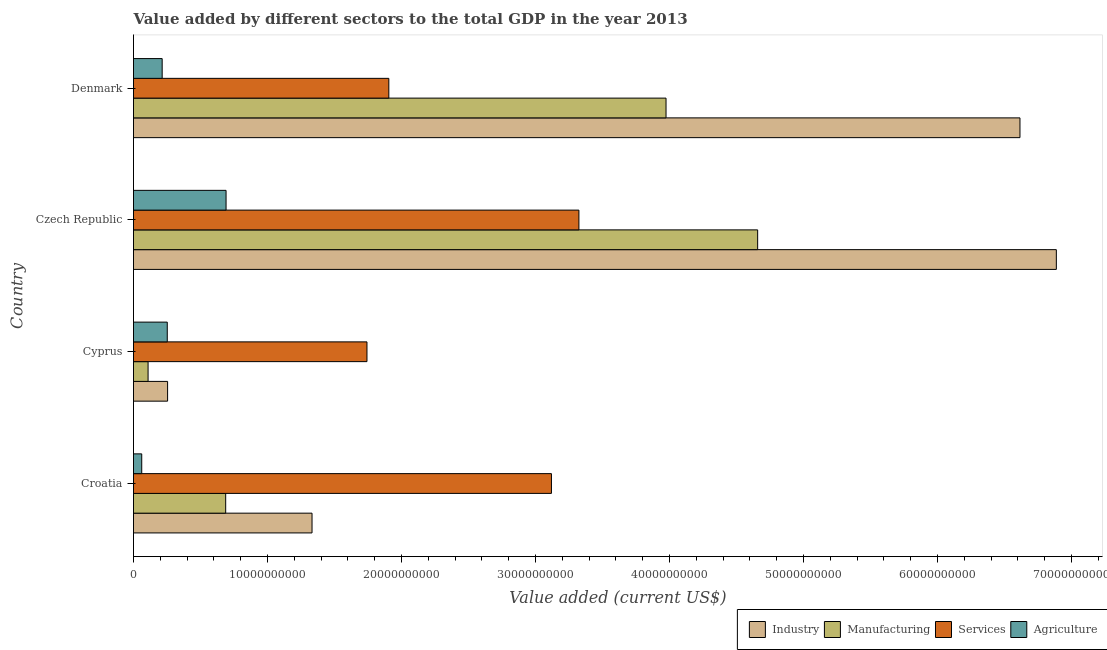Are the number of bars per tick equal to the number of legend labels?
Offer a very short reply. Yes. Are the number of bars on each tick of the Y-axis equal?
Your answer should be compact. Yes. How many bars are there on the 3rd tick from the bottom?
Provide a succinct answer. 4. What is the label of the 1st group of bars from the top?
Keep it short and to the point. Denmark. What is the value added by manufacturing sector in Cyprus?
Your response must be concise. 1.09e+09. Across all countries, what is the maximum value added by manufacturing sector?
Your answer should be compact. 4.66e+1. Across all countries, what is the minimum value added by manufacturing sector?
Keep it short and to the point. 1.09e+09. In which country was the value added by manufacturing sector maximum?
Your answer should be compact. Czech Republic. In which country was the value added by services sector minimum?
Ensure brevity in your answer.  Cyprus. What is the total value added by industrial sector in the graph?
Offer a terse response. 1.51e+11. What is the difference between the value added by industrial sector in Croatia and that in Denmark?
Keep it short and to the point. -5.28e+1. What is the difference between the value added by agricultural sector in Croatia and the value added by manufacturing sector in Cyprus?
Provide a short and direct response. -4.73e+08. What is the average value added by services sector per country?
Make the answer very short. 2.52e+1. What is the difference between the value added by manufacturing sector and value added by agricultural sector in Czech Republic?
Provide a succinct answer. 3.97e+1. What is the ratio of the value added by manufacturing sector in Cyprus to that in Denmark?
Provide a succinct answer. 0.03. Is the value added by services sector in Croatia less than that in Czech Republic?
Make the answer very short. Yes. What is the difference between the highest and the second highest value added by manufacturing sector?
Provide a short and direct response. 6.84e+09. What is the difference between the highest and the lowest value added by manufacturing sector?
Your response must be concise. 4.55e+1. What does the 4th bar from the top in Cyprus represents?
Make the answer very short. Industry. What does the 4th bar from the bottom in Denmark represents?
Ensure brevity in your answer.  Agriculture. How many bars are there?
Offer a very short reply. 16. What is the difference between two consecutive major ticks on the X-axis?
Provide a short and direct response. 1.00e+1. Are the values on the major ticks of X-axis written in scientific E-notation?
Your answer should be very brief. No. Does the graph contain any zero values?
Your answer should be very brief. No. Where does the legend appear in the graph?
Your answer should be very brief. Bottom right. How many legend labels are there?
Your answer should be very brief. 4. What is the title of the graph?
Offer a terse response. Value added by different sectors to the total GDP in the year 2013. What is the label or title of the X-axis?
Your response must be concise. Value added (current US$). What is the Value added (current US$) in Industry in Croatia?
Provide a succinct answer. 1.33e+1. What is the Value added (current US$) of Manufacturing in Croatia?
Give a very brief answer. 6.88e+09. What is the Value added (current US$) in Services in Croatia?
Ensure brevity in your answer.  3.12e+1. What is the Value added (current US$) in Agriculture in Croatia?
Provide a short and direct response. 6.14e+08. What is the Value added (current US$) in Industry in Cyprus?
Provide a short and direct response. 2.54e+09. What is the Value added (current US$) in Manufacturing in Cyprus?
Give a very brief answer. 1.09e+09. What is the Value added (current US$) in Services in Cyprus?
Your answer should be very brief. 1.74e+1. What is the Value added (current US$) of Agriculture in Cyprus?
Keep it short and to the point. 2.52e+09. What is the Value added (current US$) of Industry in Czech Republic?
Your response must be concise. 6.89e+1. What is the Value added (current US$) of Manufacturing in Czech Republic?
Give a very brief answer. 4.66e+1. What is the Value added (current US$) in Services in Czech Republic?
Your response must be concise. 3.32e+1. What is the Value added (current US$) in Agriculture in Czech Republic?
Provide a succinct answer. 6.91e+09. What is the Value added (current US$) of Industry in Denmark?
Give a very brief answer. 6.61e+1. What is the Value added (current US$) in Manufacturing in Denmark?
Offer a very short reply. 3.97e+1. What is the Value added (current US$) of Services in Denmark?
Ensure brevity in your answer.  1.91e+1. What is the Value added (current US$) in Agriculture in Denmark?
Your response must be concise. 2.14e+09. Across all countries, what is the maximum Value added (current US$) in Industry?
Your response must be concise. 6.89e+1. Across all countries, what is the maximum Value added (current US$) of Manufacturing?
Your response must be concise. 4.66e+1. Across all countries, what is the maximum Value added (current US$) of Services?
Make the answer very short. 3.32e+1. Across all countries, what is the maximum Value added (current US$) of Agriculture?
Provide a succinct answer. 6.91e+09. Across all countries, what is the minimum Value added (current US$) in Industry?
Keep it short and to the point. 2.54e+09. Across all countries, what is the minimum Value added (current US$) of Manufacturing?
Your response must be concise. 1.09e+09. Across all countries, what is the minimum Value added (current US$) in Services?
Give a very brief answer. 1.74e+1. Across all countries, what is the minimum Value added (current US$) in Agriculture?
Offer a terse response. 6.14e+08. What is the total Value added (current US$) of Industry in the graph?
Your answer should be compact. 1.51e+11. What is the total Value added (current US$) of Manufacturing in the graph?
Ensure brevity in your answer.  9.43e+1. What is the total Value added (current US$) of Services in the graph?
Provide a succinct answer. 1.01e+11. What is the total Value added (current US$) of Agriculture in the graph?
Offer a very short reply. 1.22e+1. What is the difference between the Value added (current US$) of Industry in Croatia and that in Cyprus?
Ensure brevity in your answer.  1.08e+1. What is the difference between the Value added (current US$) of Manufacturing in Croatia and that in Cyprus?
Your response must be concise. 5.79e+09. What is the difference between the Value added (current US$) of Services in Croatia and that in Cyprus?
Give a very brief answer. 1.38e+1. What is the difference between the Value added (current US$) of Agriculture in Croatia and that in Cyprus?
Keep it short and to the point. -1.90e+09. What is the difference between the Value added (current US$) in Industry in Croatia and that in Czech Republic?
Keep it short and to the point. -5.55e+1. What is the difference between the Value added (current US$) in Manufacturing in Croatia and that in Czech Republic?
Keep it short and to the point. -3.97e+1. What is the difference between the Value added (current US$) in Services in Croatia and that in Czech Republic?
Ensure brevity in your answer.  -2.05e+09. What is the difference between the Value added (current US$) in Agriculture in Croatia and that in Czech Republic?
Make the answer very short. -6.29e+09. What is the difference between the Value added (current US$) of Industry in Croatia and that in Denmark?
Your answer should be compact. -5.28e+1. What is the difference between the Value added (current US$) of Manufacturing in Croatia and that in Denmark?
Provide a succinct answer. -3.29e+1. What is the difference between the Value added (current US$) of Services in Croatia and that in Denmark?
Offer a very short reply. 1.21e+1. What is the difference between the Value added (current US$) in Agriculture in Croatia and that in Denmark?
Your response must be concise. -1.52e+09. What is the difference between the Value added (current US$) of Industry in Cyprus and that in Czech Republic?
Your answer should be compact. -6.63e+1. What is the difference between the Value added (current US$) in Manufacturing in Cyprus and that in Czech Republic?
Your response must be concise. -4.55e+1. What is the difference between the Value added (current US$) in Services in Cyprus and that in Czech Republic?
Offer a terse response. -1.58e+1. What is the difference between the Value added (current US$) of Agriculture in Cyprus and that in Czech Republic?
Offer a terse response. -4.39e+09. What is the difference between the Value added (current US$) of Industry in Cyprus and that in Denmark?
Give a very brief answer. -6.36e+1. What is the difference between the Value added (current US$) in Manufacturing in Cyprus and that in Denmark?
Your answer should be compact. -3.87e+1. What is the difference between the Value added (current US$) in Services in Cyprus and that in Denmark?
Provide a succinct answer. -1.63e+09. What is the difference between the Value added (current US$) in Agriculture in Cyprus and that in Denmark?
Your answer should be compact. 3.80e+08. What is the difference between the Value added (current US$) of Industry in Czech Republic and that in Denmark?
Your answer should be compact. 2.72e+09. What is the difference between the Value added (current US$) in Manufacturing in Czech Republic and that in Denmark?
Your response must be concise. 6.84e+09. What is the difference between the Value added (current US$) in Services in Czech Republic and that in Denmark?
Make the answer very short. 1.42e+1. What is the difference between the Value added (current US$) in Agriculture in Czech Republic and that in Denmark?
Keep it short and to the point. 4.77e+09. What is the difference between the Value added (current US$) in Industry in Croatia and the Value added (current US$) in Manufacturing in Cyprus?
Ensure brevity in your answer.  1.22e+1. What is the difference between the Value added (current US$) of Industry in Croatia and the Value added (current US$) of Services in Cyprus?
Your answer should be very brief. -4.10e+09. What is the difference between the Value added (current US$) of Industry in Croatia and the Value added (current US$) of Agriculture in Cyprus?
Your response must be concise. 1.08e+1. What is the difference between the Value added (current US$) in Manufacturing in Croatia and the Value added (current US$) in Services in Cyprus?
Provide a succinct answer. -1.05e+1. What is the difference between the Value added (current US$) in Manufacturing in Croatia and the Value added (current US$) in Agriculture in Cyprus?
Make the answer very short. 4.36e+09. What is the difference between the Value added (current US$) of Services in Croatia and the Value added (current US$) of Agriculture in Cyprus?
Your answer should be very brief. 2.87e+1. What is the difference between the Value added (current US$) in Industry in Croatia and the Value added (current US$) in Manufacturing in Czech Republic?
Your answer should be very brief. -3.33e+1. What is the difference between the Value added (current US$) of Industry in Croatia and the Value added (current US$) of Services in Czech Republic?
Offer a very short reply. -1.99e+1. What is the difference between the Value added (current US$) of Industry in Croatia and the Value added (current US$) of Agriculture in Czech Republic?
Keep it short and to the point. 6.42e+09. What is the difference between the Value added (current US$) in Manufacturing in Croatia and the Value added (current US$) in Services in Czech Republic?
Your response must be concise. -2.64e+1. What is the difference between the Value added (current US$) in Manufacturing in Croatia and the Value added (current US$) in Agriculture in Czech Republic?
Ensure brevity in your answer.  -2.79e+07. What is the difference between the Value added (current US$) in Services in Croatia and the Value added (current US$) in Agriculture in Czech Republic?
Your answer should be very brief. 2.43e+1. What is the difference between the Value added (current US$) in Industry in Croatia and the Value added (current US$) in Manufacturing in Denmark?
Offer a very short reply. -2.64e+1. What is the difference between the Value added (current US$) of Industry in Croatia and the Value added (current US$) of Services in Denmark?
Your answer should be compact. -5.73e+09. What is the difference between the Value added (current US$) in Industry in Croatia and the Value added (current US$) in Agriculture in Denmark?
Offer a terse response. 1.12e+1. What is the difference between the Value added (current US$) in Manufacturing in Croatia and the Value added (current US$) in Services in Denmark?
Give a very brief answer. -1.22e+1. What is the difference between the Value added (current US$) in Manufacturing in Croatia and the Value added (current US$) in Agriculture in Denmark?
Ensure brevity in your answer.  4.74e+09. What is the difference between the Value added (current US$) in Services in Croatia and the Value added (current US$) in Agriculture in Denmark?
Ensure brevity in your answer.  2.90e+1. What is the difference between the Value added (current US$) in Industry in Cyprus and the Value added (current US$) in Manufacturing in Czech Republic?
Keep it short and to the point. -4.40e+1. What is the difference between the Value added (current US$) in Industry in Cyprus and the Value added (current US$) in Services in Czech Republic?
Your answer should be very brief. -3.07e+1. What is the difference between the Value added (current US$) of Industry in Cyprus and the Value added (current US$) of Agriculture in Czech Republic?
Offer a terse response. -4.36e+09. What is the difference between the Value added (current US$) of Manufacturing in Cyprus and the Value added (current US$) of Services in Czech Republic?
Offer a terse response. -3.21e+1. What is the difference between the Value added (current US$) of Manufacturing in Cyprus and the Value added (current US$) of Agriculture in Czech Republic?
Keep it short and to the point. -5.82e+09. What is the difference between the Value added (current US$) of Services in Cyprus and the Value added (current US$) of Agriculture in Czech Republic?
Offer a very short reply. 1.05e+1. What is the difference between the Value added (current US$) in Industry in Cyprus and the Value added (current US$) in Manufacturing in Denmark?
Provide a short and direct response. -3.72e+1. What is the difference between the Value added (current US$) of Industry in Cyprus and the Value added (current US$) of Services in Denmark?
Keep it short and to the point. -1.65e+1. What is the difference between the Value added (current US$) of Industry in Cyprus and the Value added (current US$) of Agriculture in Denmark?
Make the answer very short. 4.04e+08. What is the difference between the Value added (current US$) of Manufacturing in Cyprus and the Value added (current US$) of Services in Denmark?
Make the answer very short. -1.80e+1. What is the difference between the Value added (current US$) of Manufacturing in Cyprus and the Value added (current US$) of Agriculture in Denmark?
Offer a terse response. -1.05e+09. What is the difference between the Value added (current US$) of Services in Cyprus and the Value added (current US$) of Agriculture in Denmark?
Make the answer very short. 1.53e+1. What is the difference between the Value added (current US$) in Industry in Czech Republic and the Value added (current US$) in Manufacturing in Denmark?
Offer a very short reply. 2.91e+1. What is the difference between the Value added (current US$) of Industry in Czech Republic and the Value added (current US$) of Services in Denmark?
Your answer should be very brief. 4.98e+1. What is the difference between the Value added (current US$) of Industry in Czech Republic and the Value added (current US$) of Agriculture in Denmark?
Offer a very short reply. 6.67e+1. What is the difference between the Value added (current US$) in Manufacturing in Czech Republic and the Value added (current US$) in Services in Denmark?
Give a very brief answer. 2.75e+1. What is the difference between the Value added (current US$) of Manufacturing in Czech Republic and the Value added (current US$) of Agriculture in Denmark?
Your response must be concise. 4.44e+1. What is the difference between the Value added (current US$) of Services in Czech Republic and the Value added (current US$) of Agriculture in Denmark?
Your answer should be compact. 3.11e+1. What is the average Value added (current US$) of Industry per country?
Ensure brevity in your answer.  3.77e+1. What is the average Value added (current US$) of Manufacturing per country?
Your answer should be very brief. 2.36e+1. What is the average Value added (current US$) in Services per country?
Give a very brief answer. 2.52e+1. What is the average Value added (current US$) in Agriculture per country?
Provide a succinct answer. 3.04e+09. What is the difference between the Value added (current US$) of Industry and Value added (current US$) of Manufacturing in Croatia?
Offer a terse response. 6.44e+09. What is the difference between the Value added (current US$) of Industry and Value added (current US$) of Services in Croatia?
Your response must be concise. -1.79e+1. What is the difference between the Value added (current US$) of Industry and Value added (current US$) of Agriculture in Croatia?
Provide a succinct answer. 1.27e+1. What is the difference between the Value added (current US$) in Manufacturing and Value added (current US$) in Services in Croatia?
Your answer should be very brief. -2.43e+1. What is the difference between the Value added (current US$) in Manufacturing and Value added (current US$) in Agriculture in Croatia?
Ensure brevity in your answer.  6.26e+09. What is the difference between the Value added (current US$) in Services and Value added (current US$) in Agriculture in Croatia?
Give a very brief answer. 3.06e+1. What is the difference between the Value added (current US$) of Industry and Value added (current US$) of Manufacturing in Cyprus?
Offer a very short reply. 1.46e+09. What is the difference between the Value added (current US$) of Industry and Value added (current US$) of Services in Cyprus?
Give a very brief answer. -1.49e+1. What is the difference between the Value added (current US$) in Industry and Value added (current US$) in Agriculture in Cyprus?
Make the answer very short. 2.38e+07. What is the difference between the Value added (current US$) in Manufacturing and Value added (current US$) in Services in Cyprus?
Provide a succinct answer. -1.63e+1. What is the difference between the Value added (current US$) in Manufacturing and Value added (current US$) in Agriculture in Cyprus?
Provide a succinct answer. -1.43e+09. What is the difference between the Value added (current US$) of Services and Value added (current US$) of Agriculture in Cyprus?
Keep it short and to the point. 1.49e+1. What is the difference between the Value added (current US$) in Industry and Value added (current US$) in Manufacturing in Czech Republic?
Provide a short and direct response. 2.23e+1. What is the difference between the Value added (current US$) of Industry and Value added (current US$) of Services in Czech Republic?
Provide a succinct answer. 3.56e+1. What is the difference between the Value added (current US$) of Industry and Value added (current US$) of Agriculture in Czech Republic?
Offer a very short reply. 6.20e+1. What is the difference between the Value added (current US$) in Manufacturing and Value added (current US$) in Services in Czech Republic?
Keep it short and to the point. 1.33e+1. What is the difference between the Value added (current US$) in Manufacturing and Value added (current US$) in Agriculture in Czech Republic?
Your response must be concise. 3.97e+1. What is the difference between the Value added (current US$) in Services and Value added (current US$) in Agriculture in Czech Republic?
Your answer should be compact. 2.63e+1. What is the difference between the Value added (current US$) of Industry and Value added (current US$) of Manufacturing in Denmark?
Make the answer very short. 2.64e+1. What is the difference between the Value added (current US$) in Industry and Value added (current US$) in Services in Denmark?
Give a very brief answer. 4.71e+1. What is the difference between the Value added (current US$) of Industry and Value added (current US$) of Agriculture in Denmark?
Offer a very short reply. 6.40e+1. What is the difference between the Value added (current US$) of Manufacturing and Value added (current US$) of Services in Denmark?
Your answer should be compact. 2.07e+1. What is the difference between the Value added (current US$) of Manufacturing and Value added (current US$) of Agriculture in Denmark?
Your answer should be very brief. 3.76e+1. What is the difference between the Value added (current US$) in Services and Value added (current US$) in Agriculture in Denmark?
Make the answer very short. 1.69e+1. What is the ratio of the Value added (current US$) of Industry in Croatia to that in Cyprus?
Provide a short and direct response. 5.24. What is the ratio of the Value added (current US$) in Manufacturing in Croatia to that in Cyprus?
Offer a terse response. 6.33. What is the ratio of the Value added (current US$) of Services in Croatia to that in Cyprus?
Give a very brief answer. 1.79. What is the ratio of the Value added (current US$) of Agriculture in Croatia to that in Cyprus?
Offer a terse response. 0.24. What is the ratio of the Value added (current US$) in Industry in Croatia to that in Czech Republic?
Your answer should be compact. 0.19. What is the ratio of the Value added (current US$) in Manufacturing in Croatia to that in Czech Republic?
Keep it short and to the point. 0.15. What is the ratio of the Value added (current US$) in Services in Croatia to that in Czech Republic?
Offer a very short reply. 0.94. What is the ratio of the Value added (current US$) in Agriculture in Croatia to that in Czech Republic?
Ensure brevity in your answer.  0.09. What is the ratio of the Value added (current US$) in Industry in Croatia to that in Denmark?
Offer a terse response. 0.2. What is the ratio of the Value added (current US$) in Manufacturing in Croatia to that in Denmark?
Offer a terse response. 0.17. What is the ratio of the Value added (current US$) in Services in Croatia to that in Denmark?
Ensure brevity in your answer.  1.64. What is the ratio of the Value added (current US$) of Agriculture in Croatia to that in Denmark?
Give a very brief answer. 0.29. What is the ratio of the Value added (current US$) of Industry in Cyprus to that in Czech Republic?
Give a very brief answer. 0.04. What is the ratio of the Value added (current US$) in Manufacturing in Cyprus to that in Czech Republic?
Make the answer very short. 0.02. What is the ratio of the Value added (current US$) in Services in Cyprus to that in Czech Republic?
Ensure brevity in your answer.  0.52. What is the ratio of the Value added (current US$) in Agriculture in Cyprus to that in Czech Republic?
Provide a succinct answer. 0.36. What is the ratio of the Value added (current US$) of Industry in Cyprus to that in Denmark?
Ensure brevity in your answer.  0.04. What is the ratio of the Value added (current US$) of Manufacturing in Cyprus to that in Denmark?
Give a very brief answer. 0.03. What is the ratio of the Value added (current US$) of Services in Cyprus to that in Denmark?
Give a very brief answer. 0.91. What is the ratio of the Value added (current US$) in Agriculture in Cyprus to that in Denmark?
Your answer should be very brief. 1.18. What is the ratio of the Value added (current US$) of Industry in Czech Republic to that in Denmark?
Give a very brief answer. 1.04. What is the ratio of the Value added (current US$) of Manufacturing in Czech Republic to that in Denmark?
Ensure brevity in your answer.  1.17. What is the ratio of the Value added (current US$) in Services in Czech Republic to that in Denmark?
Provide a short and direct response. 1.74. What is the ratio of the Value added (current US$) of Agriculture in Czech Republic to that in Denmark?
Provide a short and direct response. 3.23. What is the difference between the highest and the second highest Value added (current US$) of Industry?
Offer a very short reply. 2.72e+09. What is the difference between the highest and the second highest Value added (current US$) of Manufacturing?
Keep it short and to the point. 6.84e+09. What is the difference between the highest and the second highest Value added (current US$) of Services?
Your response must be concise. 2.05e+09. What is the difference between the highest and the second highest Value added (current US$) of Agriculture?
Your answer should be very brief. 4.39e+09. What is the difference between the highest and the lowest Value added (current US$) of Industry?
Your answer should be compact. 6.63e+1. What is the difference between the highest and the lowest Value added (current US$) in Manufacturing?
Your answer should be compact. 4.55e+1. What is the difference between the highest and the lowest Value added (current US$) of Services?
Make the answer very short. 1.58e+1. What is the difference between the highest and the lowest Value added (current US$) of Agriculture?
Offer a very short reply. 6.29e+09. 